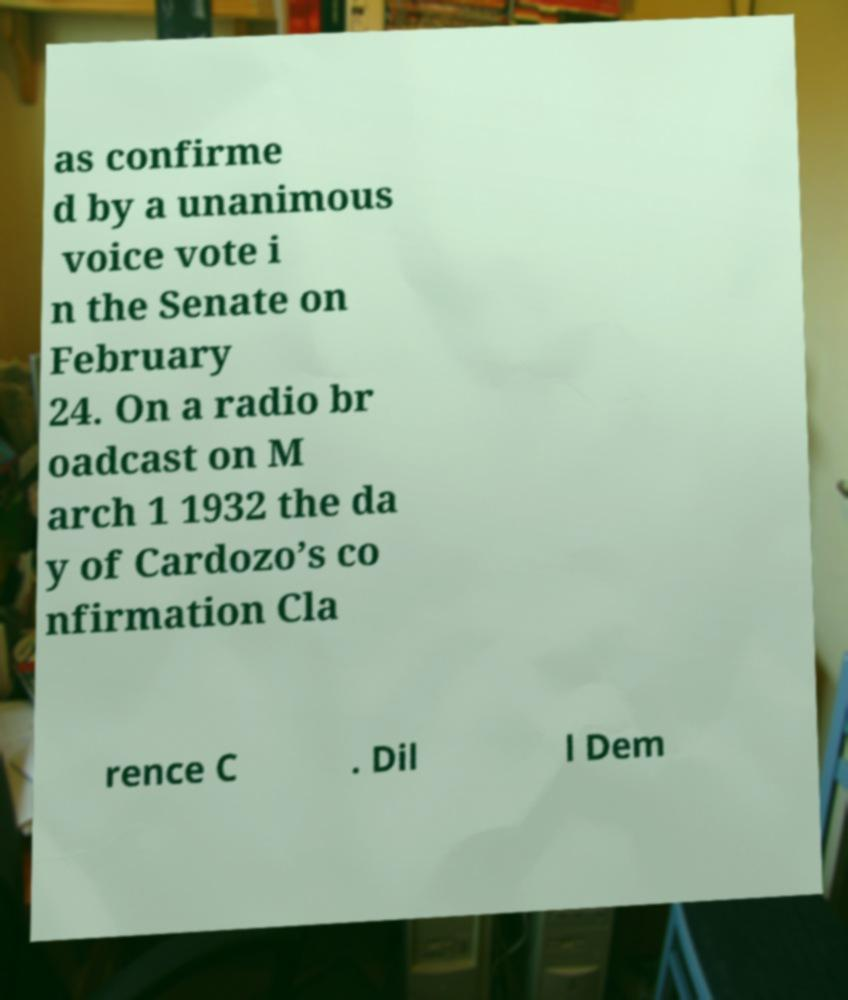Can you accurately transcribe the text from the provided image for me? as confirme d by a unanimous voice vote i n the Senate on February 24. On a radio br oadcast on M arch 1 1932 the da y of Cardozo’s co nfirmation Cla rence C . Dil l Dem 